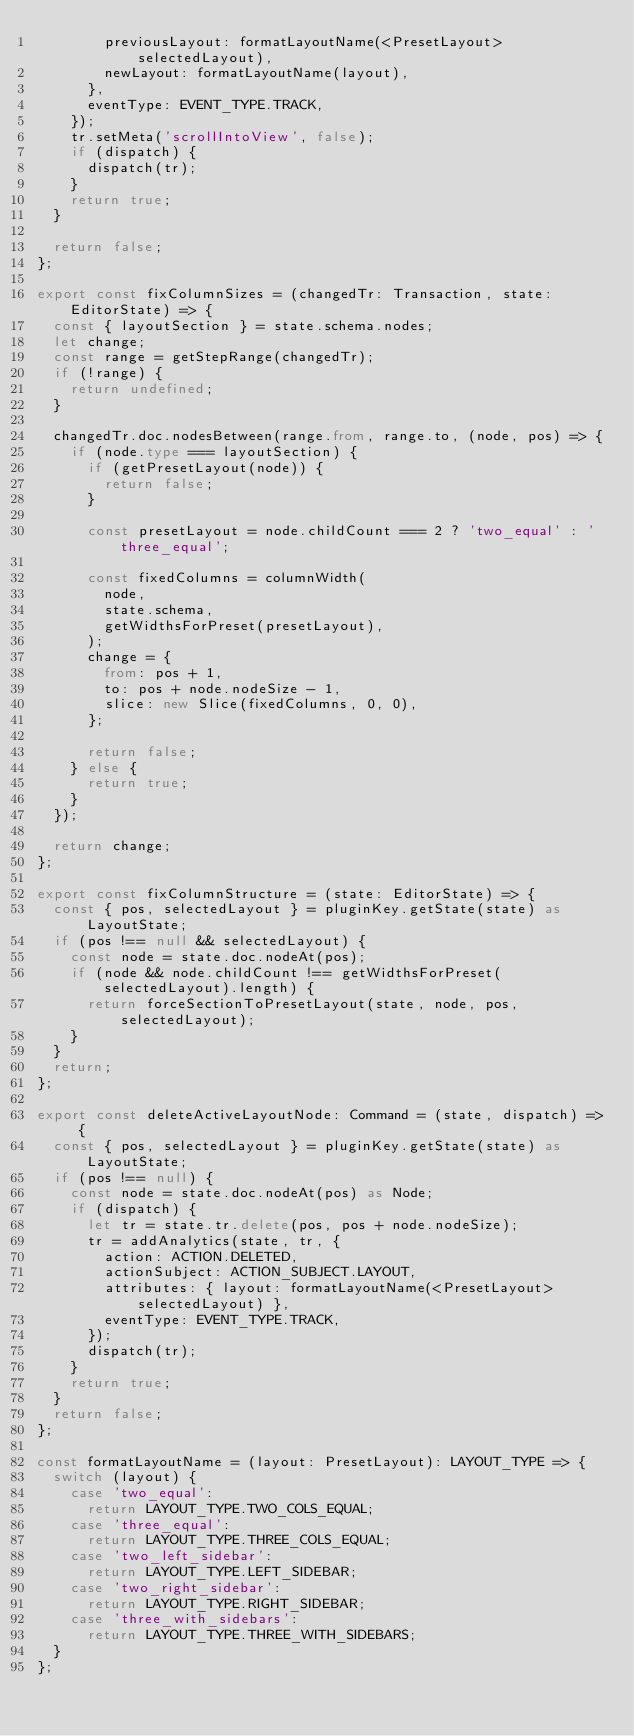Convert code to text. <code><loc_0><loc_0><loc_500><loc_500><_TypeScript_>        previousLayout: formatLayoutName(<PresetLayout>selectedLayout),
        newLayout: formatLayoutName(layout),
      },
      eventType: EVENT_TYPE.TRACK,
    });
    tr.setMeta('scrollIntoView', false);
    if (dispatch) {
      dispatch(tr);
    }
    return true;
  }

  return false;
};

export const fixColumnSizes = (changedTr: Transaction, state: EditorState) => {
  const { layoutSection } = state.schema.nodes;
  let change;
  const range = getStepRange(changedTr);
  if (!range) {
    return undefined;
  }

  changedTr.doc.nodesBetween(range.from, range.to, (node, pos) => {
    if (node.type === layoutSection) {
      if (getPresetLayout(node)) {
        return false;
      }

      const presetLayout = node.childCount === 2 ? 'two_equal' : 'three_equal';

      const fixedColumns = columnWidth(
        node,
        state.schema,
        getWidthsForPreset(presetLayout),
      );
      change = {
        from: pos + 1,
        to: pos + node.nodeSize - 1,
        slice: new Slice(fixedColumns, 0, 0),
      };

      return false;
    } else {
      return true;
    }
  });

  return change;
};

export const fixColumnStructure = (state: EditorState) => {
  const { pos, selectedLayout } = pluginKey.getState(state) as LayoutState;
  if (pos !== null && selectedLayout) {
    const node = state.doc.nodeAt(pos);
    if (node && node.childCount !== getWidthsForPreset(selectedLayout).length) {
      return forceSectionToPresetLayout(state, node, pos, selectedLayout);
    }
  }
  return;
};

export const deleteActiveLayoutNode: Command = (state, dispatch) => {
  const { pos, selectedLayout } = pluginKey.getState(state) as LayoutState;
  if (pos !== null) {
    const node = state.doc.nodeAt(pos) as Node;
    if (dispatch) {
      let tr = state.tr.delete(pos, pos + node.nodeSize);
      tr = addAnalytics(state, tr, {
        action: ACTION.DELETED,
        actionSubject: ACTION_SUBJECT.LAYOUT,
        attributes: { layout: formatLayoutName(<PresetLayout>selectedLayout) },
        eventType: EVENT_TYPE.TRACK,
      });
      dispatch(tr);
    }
    return true;
  }
  return false;
};

const formatLayoutName = (layout: PresetLayout): LAYOUT_TYPE => {
  switch (layout) {
    case 'two_equal':
      return LAYOUT_TYPE.TWO_COLS_EQUAL;
    case 'three_equal':
      return LAYOUT_TYPE.THREE_COLS_EQUAL;
    case 'two_left_sidebar':
      return LAYOUT_TYPE.LEFT_SIDEBAR;
    case 'two_right_sidebar':
      return LAYOUT_TYPE.RIGHT_SIDEBAR;
    case 'three_with_sidebars':
      return LAYOUT_TYPE.THREE_WITH_SIDEBARS;
  }
};
</code> 